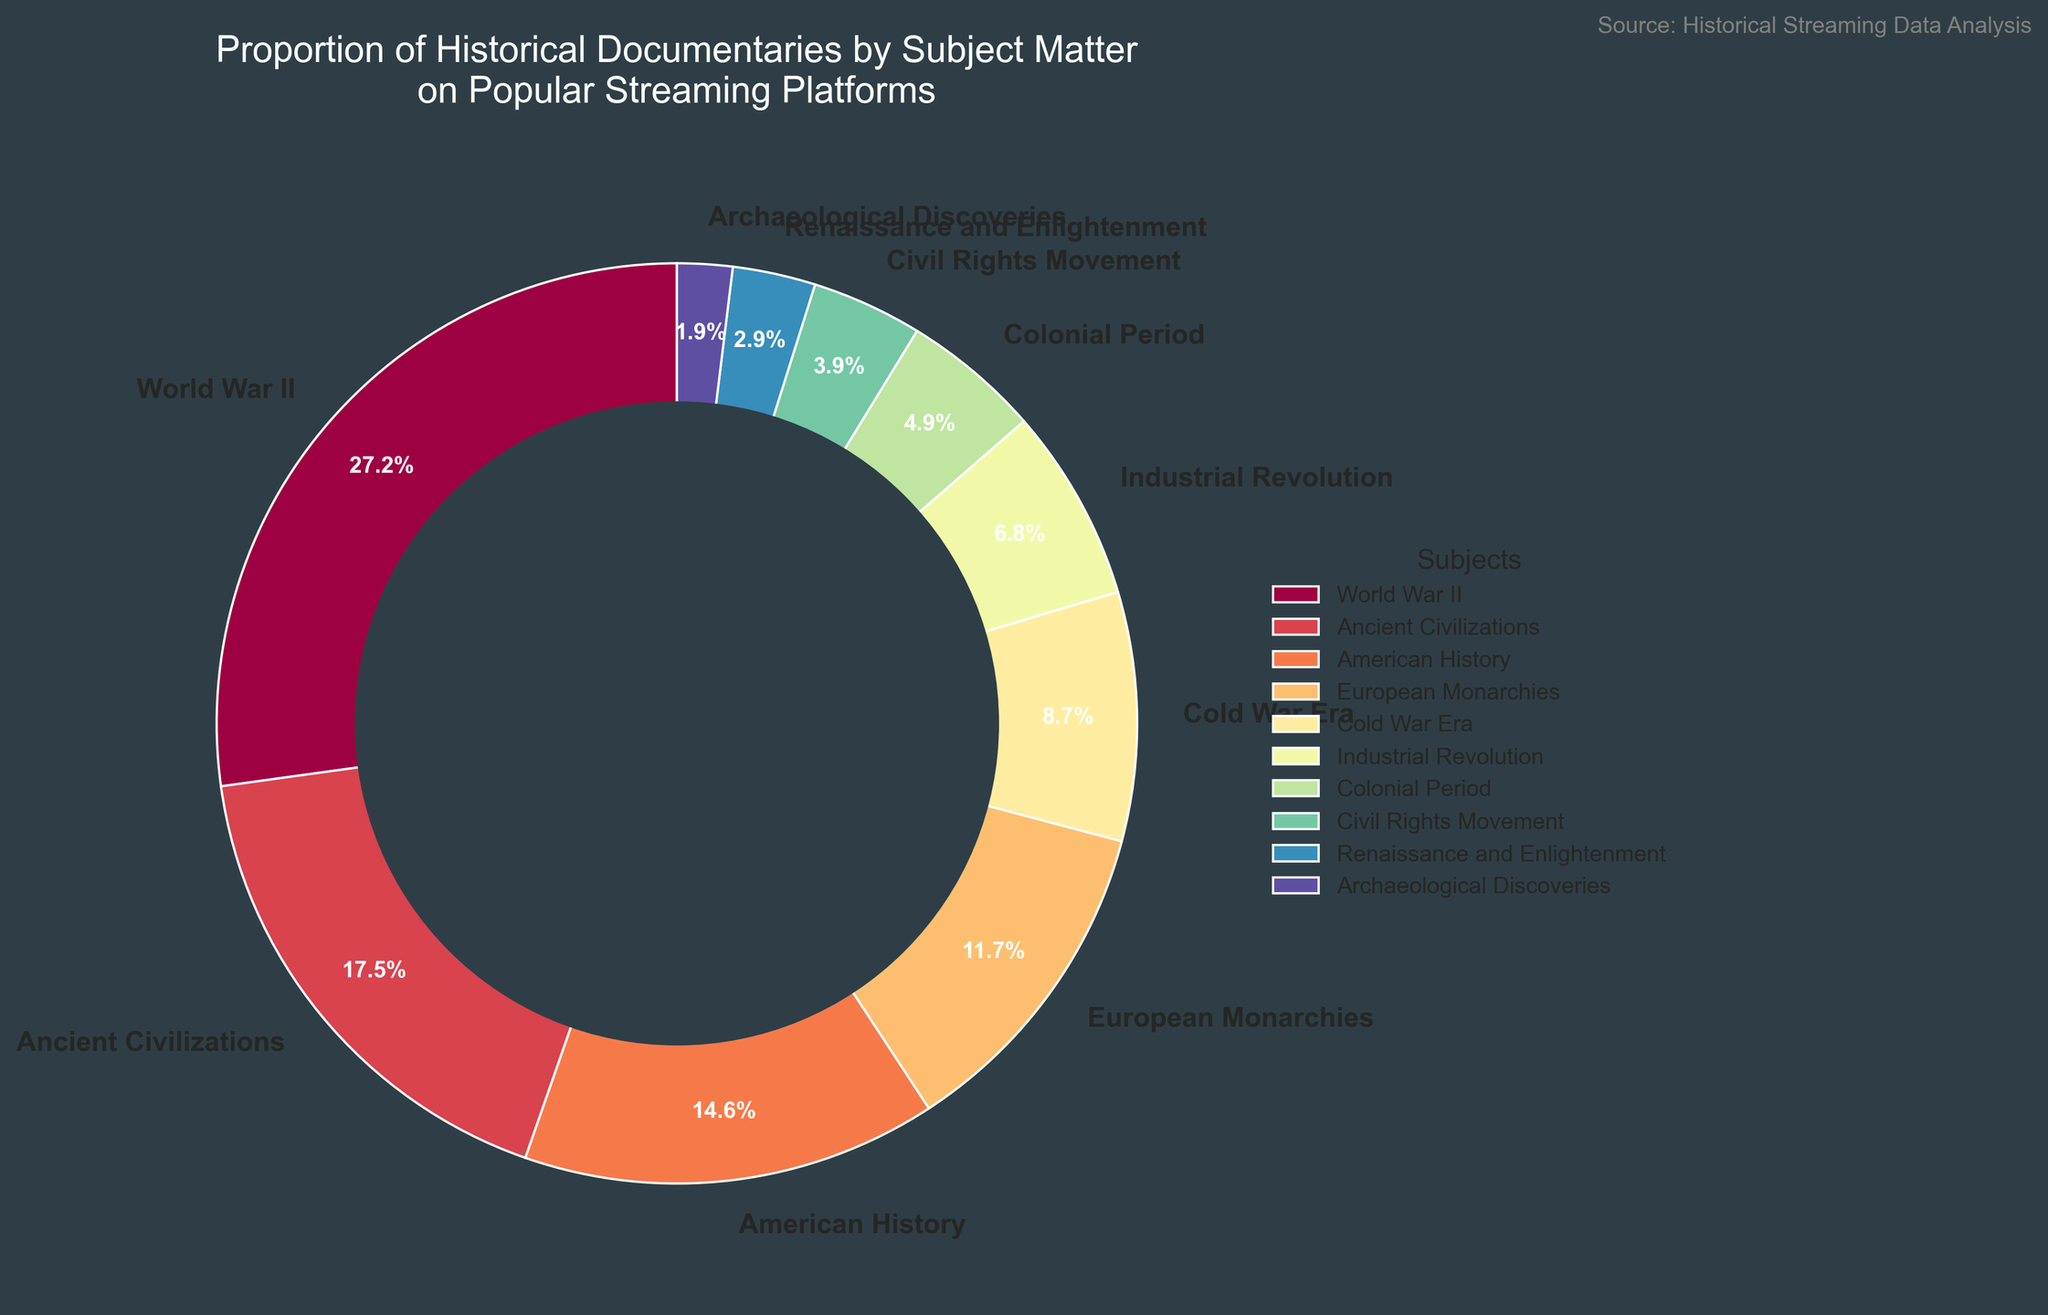Which subject has the highest proportion of historical documentaries? The segment for "World War II" is the largest in the pie chart with a value of 28%.
Answer: World War II What is the total percentage of documentaries about Ancient Civilizations and American History? The percentage for Ancient Civilizations is 18% and for American History is 15%. Summing them up gives 18% + 15% = 33%.
Answer: 33% Which subjects have a percentage less than 10%? The segments for Cold War Era (9%), Industrial Revolution (7%), Colonial Period (5%), Civil Rights Movement (4%), Renaissance and Enlightenment (3%), and Archaeological Discoveries (2%) all are less than 10%.
Answer: Cold War Era, Industrial Revolution, Colonial Period, Civil Rights Movement, Renaissance and Enlightenment, Archaeological Discoveries How much greater is the percentage of documentaries on World War II than on Cold War Era? The percentage for World War II is 28% and for Cold War Era is 9%. The difference is 28% - 9% = 19%.
Answer: 19% Which subjects combined account for exactly half of the total documentaries (50%)? Combining American History (15%) and European Monarchies (12%) gives 15% + 12% = 27%. Adding Cold War Era's (9%) makes it 27% + 9% = 36%. Including Industrial Revolution (7%) brings it to 36% + 7% = 43%. Lastly adding Colonial Period (5%) gives 43% + 5% = 48%, not 50%. Therefore, combinations do not exactly match 50%.
Answer: None What is the average percentage of documentaries for subjects listed with less than 10%? The percentages listed under 10% are 9%, 7%, 5%, 4%, 3%, and 2%. The sum is 9% + 7% + 5% + 4% + 3% + 2% = 30%. Dividing this by the number of subjects (6) gives 30% / 6 = 5%.
Answer: 5% Which subject has the smallest proportion of historical documentaries? The segment for Archaeological Discoveries is the smallest with a value of 2%.
Answer: Archaeological Discoveries 